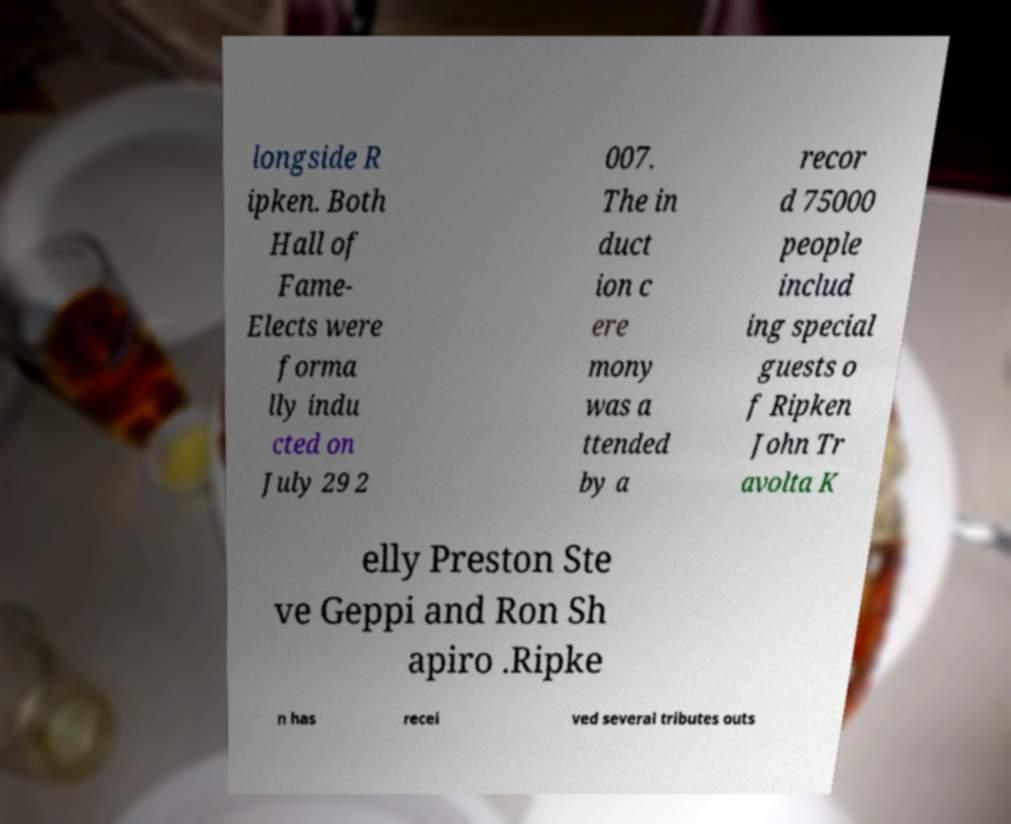Can you accurately transcribe the text from the provided image for me? longside R ipken. Both Hall of Fame- Elects were forma lly indu cted on July 29 2 007. The in duct ion c ere mony was a ttended by a recor d 75000 people includ ing special guests o f Ripken John Tr avolta K elly Preston Ste ve Geppi and Ron Sh apiro .Ripke n has recei ved several tributes outs 